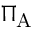<formula> <loc_0><loc_0><loc_500><loc_500>\Pi _ { A }</formula> 